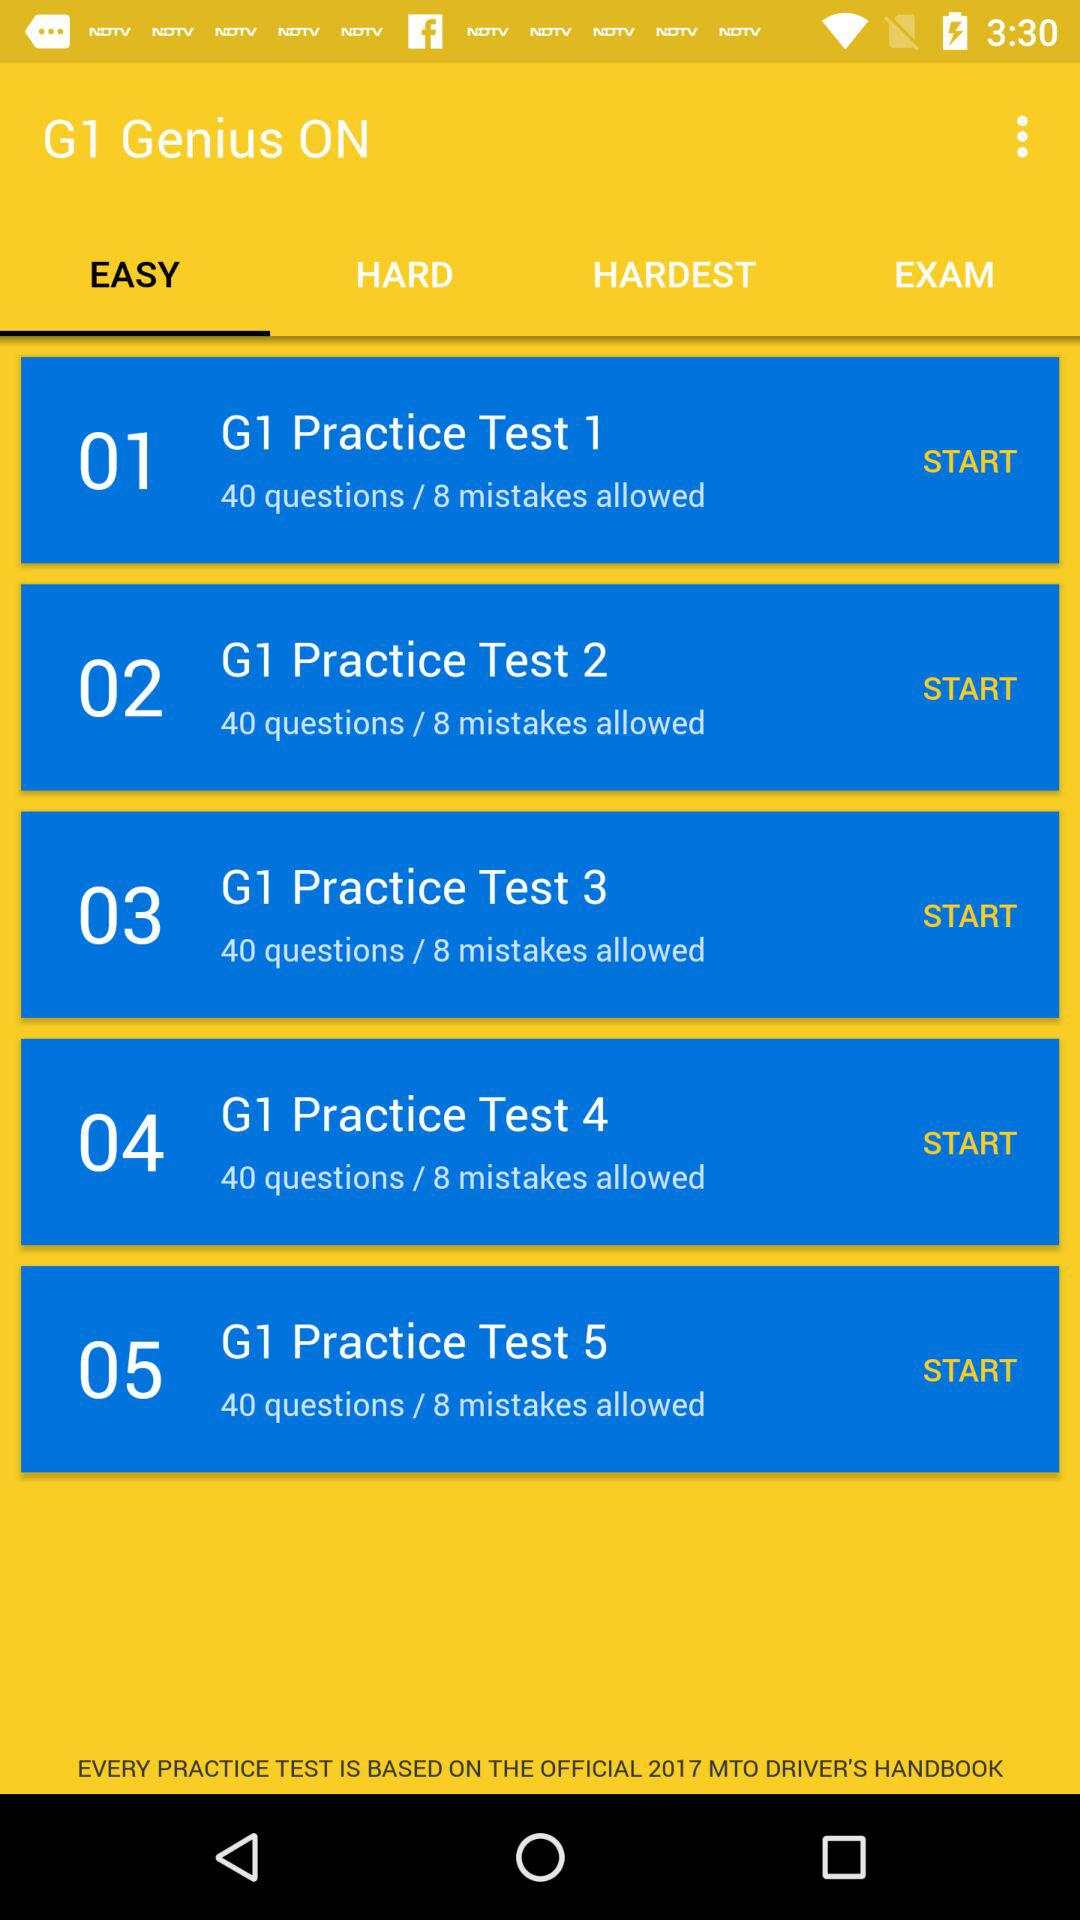How many errors are allowed in "G1 Practice Test 2"? The number of allowed errors is 8. 